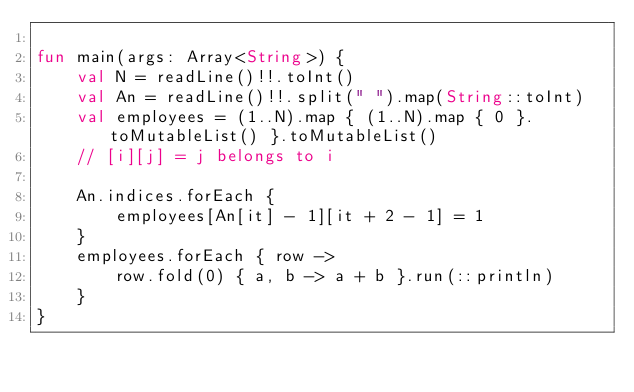Convert code to text. <code><loc_0><loc_0><loc_500><loc_500><_Kotlin_>
fun main(args: Array<String>) {
    val N = readLine()!!.toInt()
    val An = readLine()!!.split(" ").map(String::toInt)
    val employees = (1..N).map { (1..N).map { 0 }.toMutableList() }.toMutableList()
    // [i][j] = j belongs to i

    An.indices.forEach {
        employees[An[it] - 1][it + 2 - 1] = 1
    }
    employees.forEach { row -> 
        row.fold(0) { a, b -> a + b }.run(::println)
    }
}</code> 